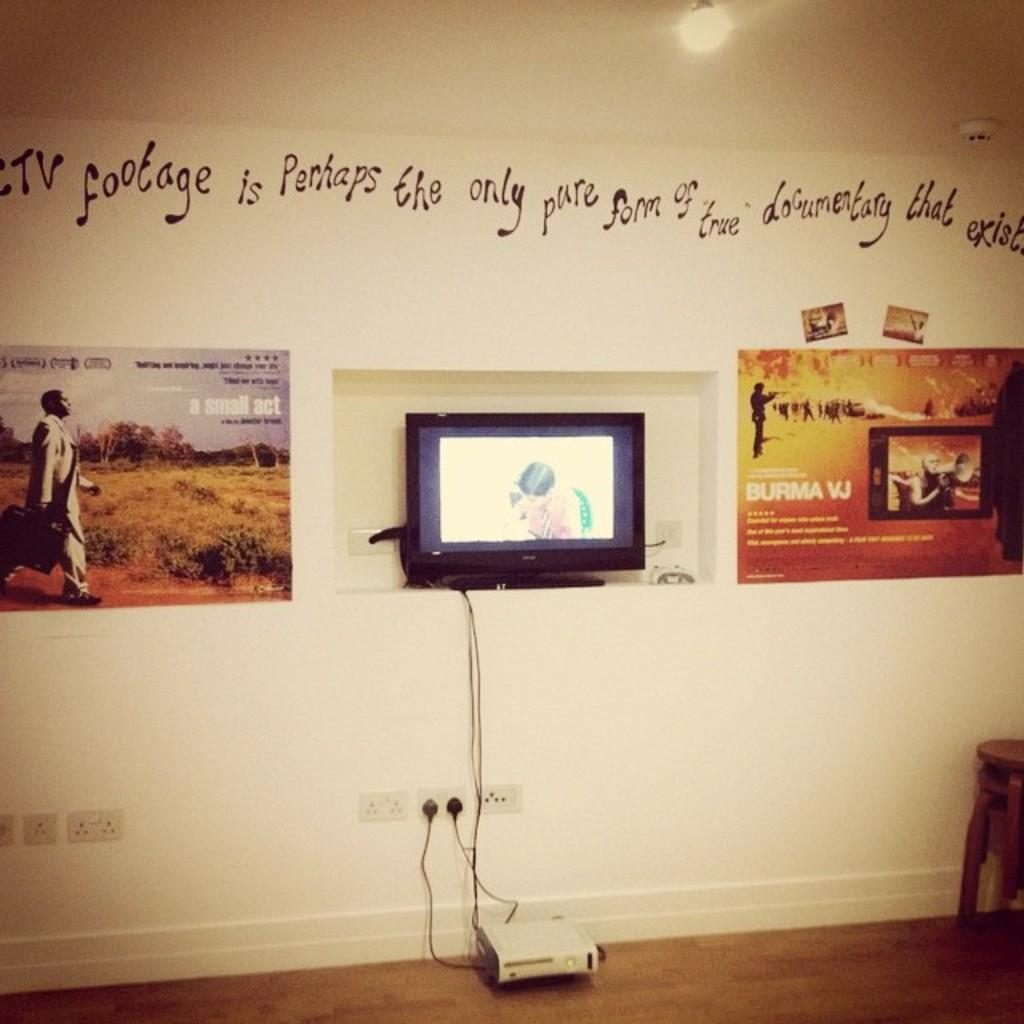<image>
Write a terse but informative summary of the picture. a wall of a museum showing colorful posters and words at the to read TV Footage 